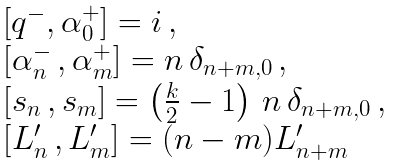<formula> <loc_0><loc_0><loc_500><loc_500>\begin{array} { l } { { [ q ^ { - } , \alpha _ { 0 } ^ { + } ] = i \, , } } \\ { { \left [ \alpha _ { n } ^ { - } \, , \alpha _ { m } ^ { + } \right ] = n \, \delta _ { n + m , 0 } \, , } } \\ { { \left [ s _ { n } \, , s _ { m } \right ] = \left ( \frac { k } { 2 } - 1 \right ) \, n \, \delta _ { n + m , 0 } \, , } } \\ { { \left [ L _ { n } ^ { \prime } \, , L _ { m } ^ { \prime } \right ] = ( n - m ) L _ { n + m } ^ { \prime } } } \end{array}</formula> 